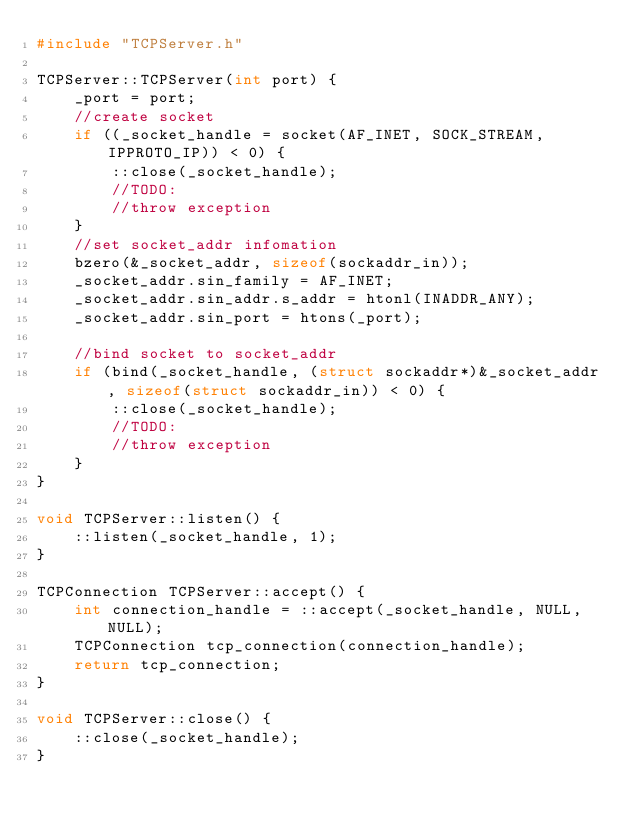<code> <loc_0><loc_0><loc_500><loc_500><_C++_>#include "TCPServer.h"

TCPServer::TCPServer(int port) {
    _port = port;
    //create socket
    if ((_socket_handle = socket(AF_INET, SOCK_STREAM, IPPROTO_IP)) < 0) {
        ::close(_socket_handle);
        //TODO:
        //throw exception
    }
    //set socket_addr infomation
    bzero(&_socket_addr, sizeof(sockaddr_in));
    _socket_addr.sin_family = AF_INET;
    _socket_addr.sin_addr.s_addr = htonl(INADDR_ANY);
    _socket_addr.sin_port = htons(_port);

    //bind socket to socket_addr
    if (bind(_socket_handle, (struct sockaddr*)&_socket_addr, sizeof(struct sockaddr_in)) < 0) {
        ::close(_socket_handle);
        //TODO:
        //throw exception
    } 
}

void TCPServer::listen() {
    ::listen(_socket_handle, 1);
}

TCPConnection TCPServer::accept() {
    int connection_handle = ::accept(_socket_handle, NULL, NULL);
    TCPConnection tcp_connection(connection_handle);
    return tcp_connection;
}

void TCPServer::close() {
    ::close(_socket_handle); 
}

</code> 